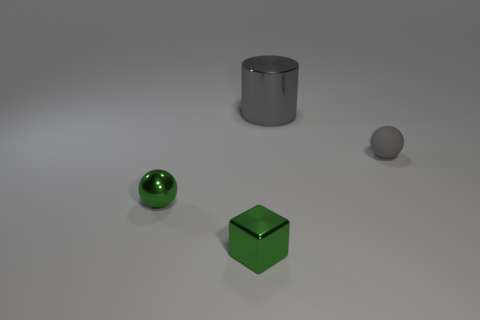Add 3 gray shiny cylinders. How many objects exist? 7 Subtract all blocks. How many objects are left? 3 Add 3 small blocks. How many small blocks exist? 4 Subtract 0 gray blocks. How many objects are left? 4 Subtract all purple matte spheres. Subtract all small green cubes. How many objects are left? 3 Add 3 spheres. How many spheres are left? 5 